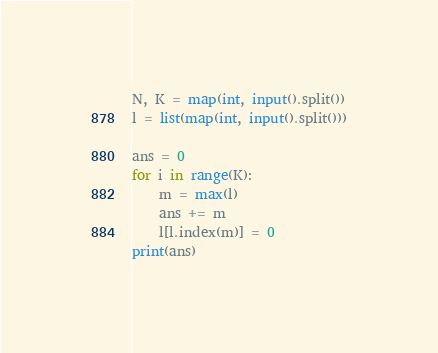<code> <loc_0><loc_0><loc_500><loc_500><_Python_>N, K = map(int, input().split())
l = list(map(int, input().split()))

ans = 0
for i in range(K):
	m = max(l)
	ans += m
	l[l.index(m)] = 0
print(ans)</code> 